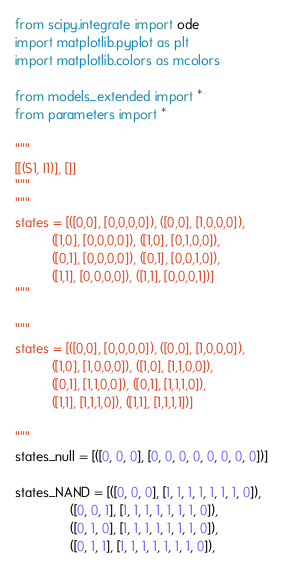Convert code to text. <code><loc_0><loc_0><loc_500><loc_500><_Python_>from scipy.integrate import ode
import matplotlib.pyplot as plt
import matplotlib.colors as mcolors

from models_extended import *
from parameters import *

"""
[[(S1, I1)], []]
"""
"""
states = [([0,0], [0,0,0,0]), ([0,0], [1,0,0,0]), 
          ([1,0], [0,0,0,0]), ([1,0], [0,1,0,0]), 
          ([0,1], [0,0,0,0]), ([0,1], [0,0,1,0]), 
          ([1,1], [0,0,0,0]), ([1,1], [0,0,0,1])]
"""

"""
states = [([0,0], [0,0,0,0]), ([0,0], [1,0,0,0]), 
          ([1,0], [1,0,0,0]), ([1,0], [1,1,0,0]), 
          ([0,1], [1,1,0,0]), ([0,1], [1,1,1,0]), 
          ([1,1], [1,1,1,0]), ([1,1], [1,1,1,1])]

"""
states_null = [([0, 0, 0], [0, 0, 0, 0, 0, 0, 0, 0])]

states_NAND = [([0, 0, 0], [1, 1, 1, 1, 1, 1, 1, 0]),
               ([0, 0, 1], [1, 1, 1, 1, 1, 1, 1, 0]),
               ([0, 1, 0], [1, 1, 1, 1, 1, 1, 1, 0]),
               ([0, 1, 1], [1, 1, 1, 1, 1, 1, 1, 0]),</code> 